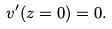<formula> <loc_0><loc_0><loc_500><loc_500>v ^ { \prime } ( z = 0 ) = 0 .</formula> 